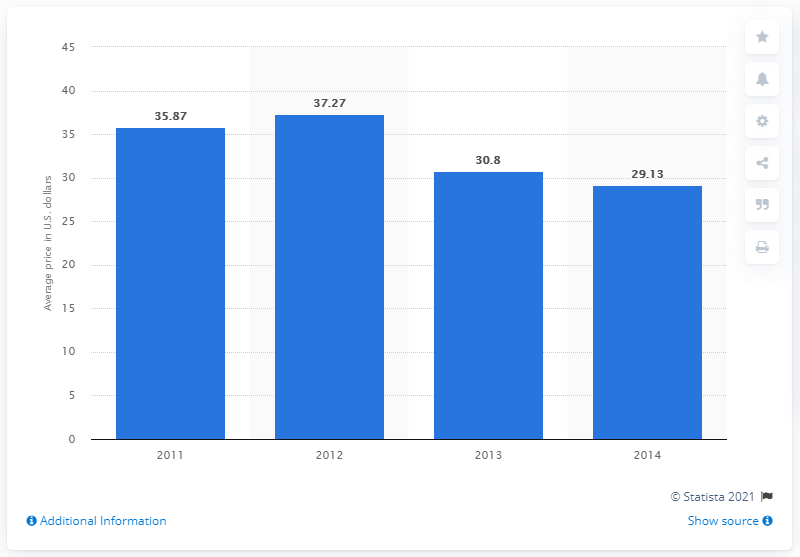Highlight a few significant elements in this photo. In 2014, the average cost of a full set of acrylic toenails at a nail salon was approximately $29.13. 